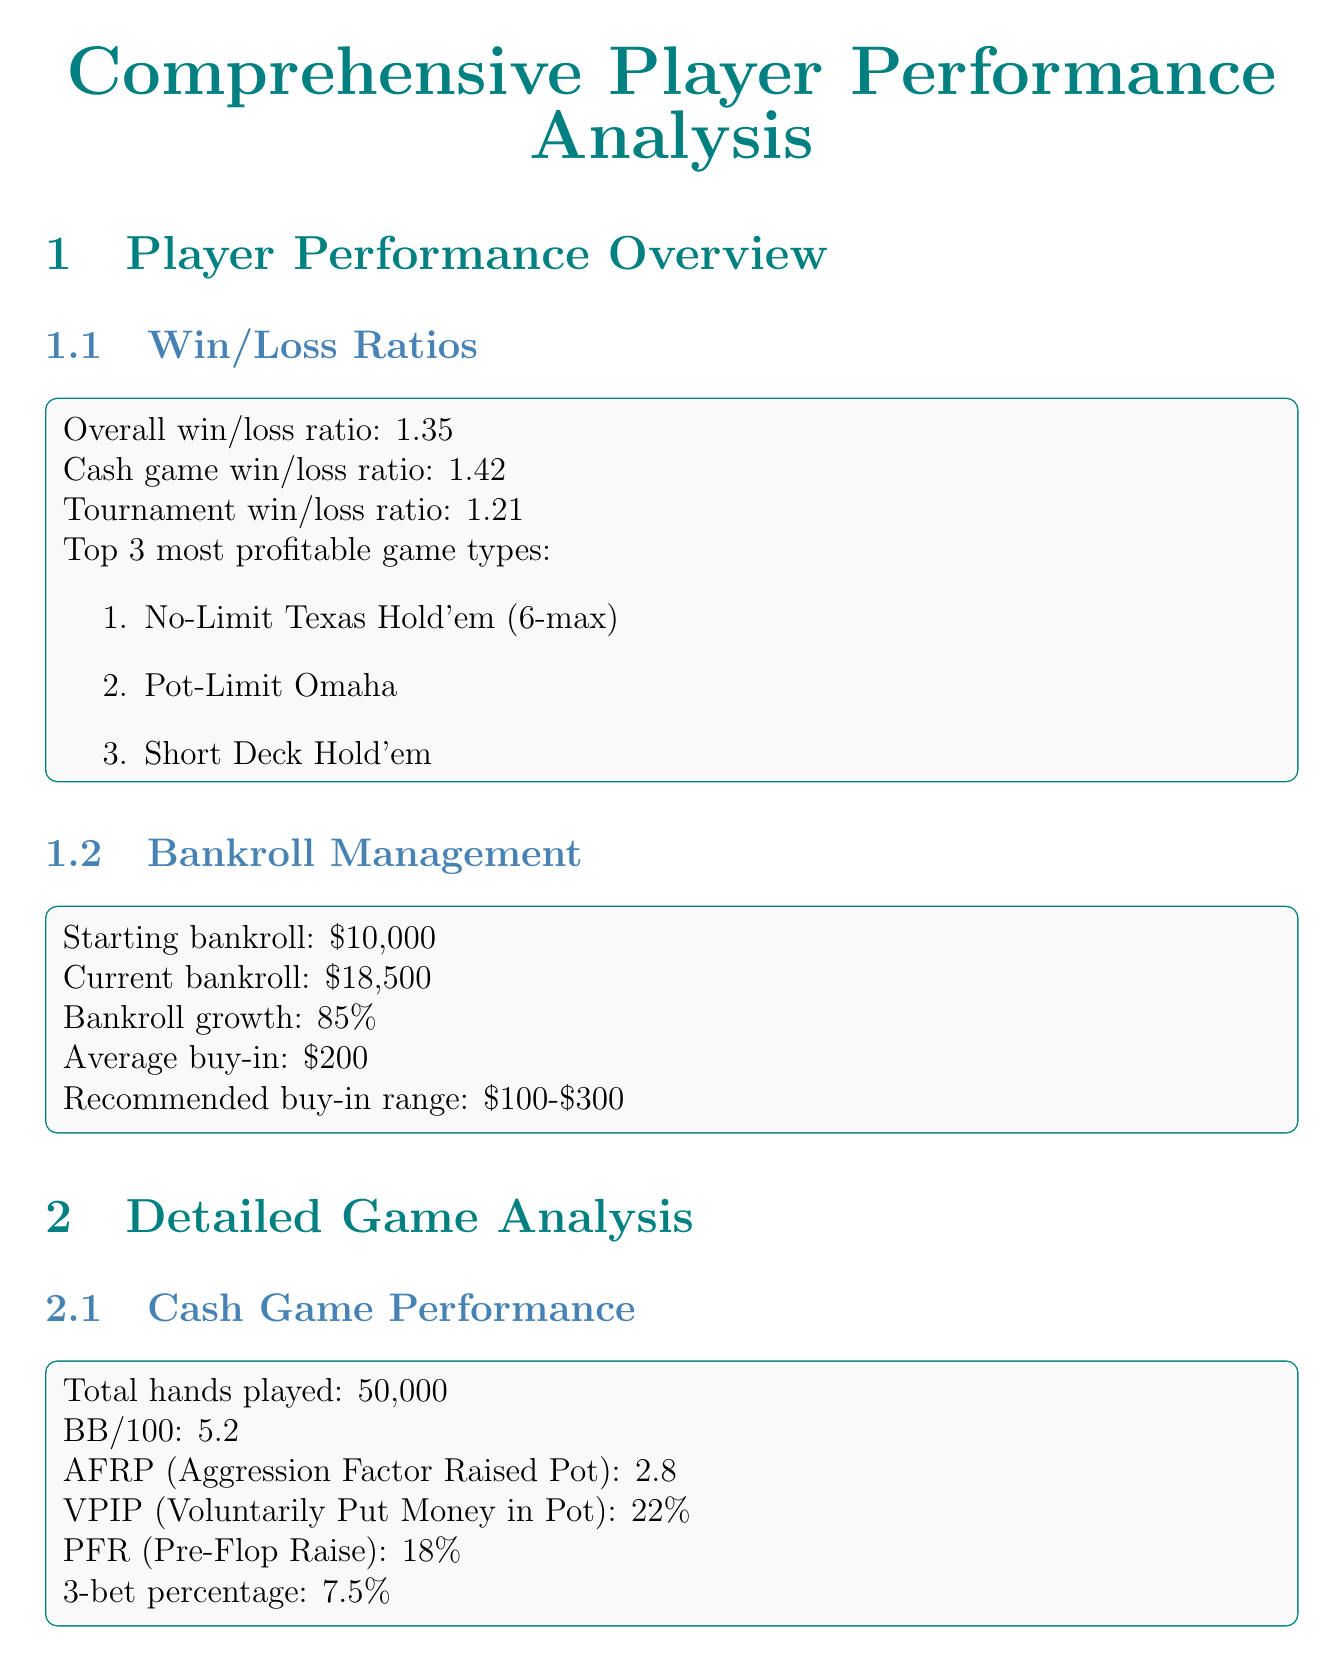What is the overall win/loss ratio? The overall win/loss ratio is stated in the Player Performance Overview section.
Answer: 1.35 What is the current bankroll? The current bankroll is found under Bankroll Management.
Answer: $18,500 How many total hands were played in cash games? This statistic is located in the Cash Game Performance subsection.
Answer: 50,000 What is the ROI for tournaments? The ROI is mentioned in the Tournament Performance subsection.
Answer: 22% What are the recommended playing hours on weekdays? This information is in the Recommended Playing Hours section.
Answer: 8 PM - 12 AM EST What is the biggest tilt trigger? The most prominent tilt trigger can be found in the Tilt Triggers section.
Answer: Multiple bad beats in short succession Which game type has the highest win/loss ratio? This information is detailed in the Win/Loss Ratios subsection.
Answer: No-Limit Texas Hold'em (6-max) Who are the most profitable opponents? The information is found in the Most Profitable Opponents subsection.
Answer: PokerBro92, RiverRat77, AllInAnnie What is an area for improvement? Areas for improvement can be found in the Skill Development Plan section.
Answer: 3-bet and 4-bet pot play What is the average ITM finish in tournaments? This statistic is provided in the Tournament Performance subsection.
Answer: 14th place 